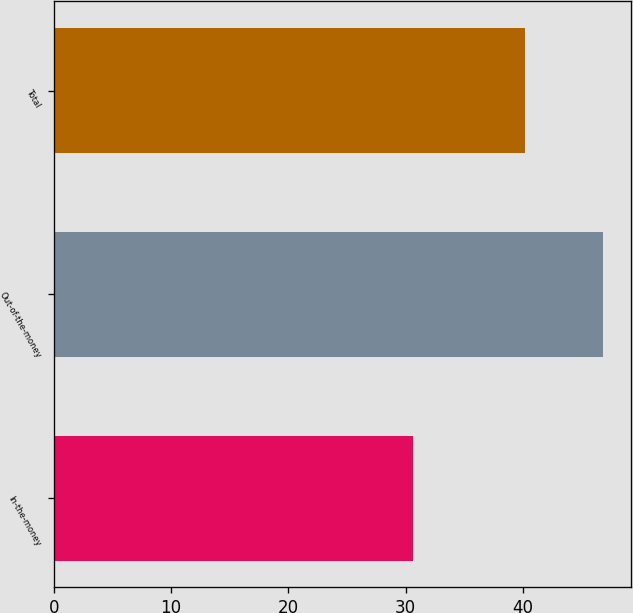<chart> <loc_0><loc_0><loc_500><loc_500><bar_chart><fcel>In-the-money<fcel>Out-of-the-money<fcel>Total<nl><fcel>30.61<fcel>46.83<fcel>40.14<nl></chart> 